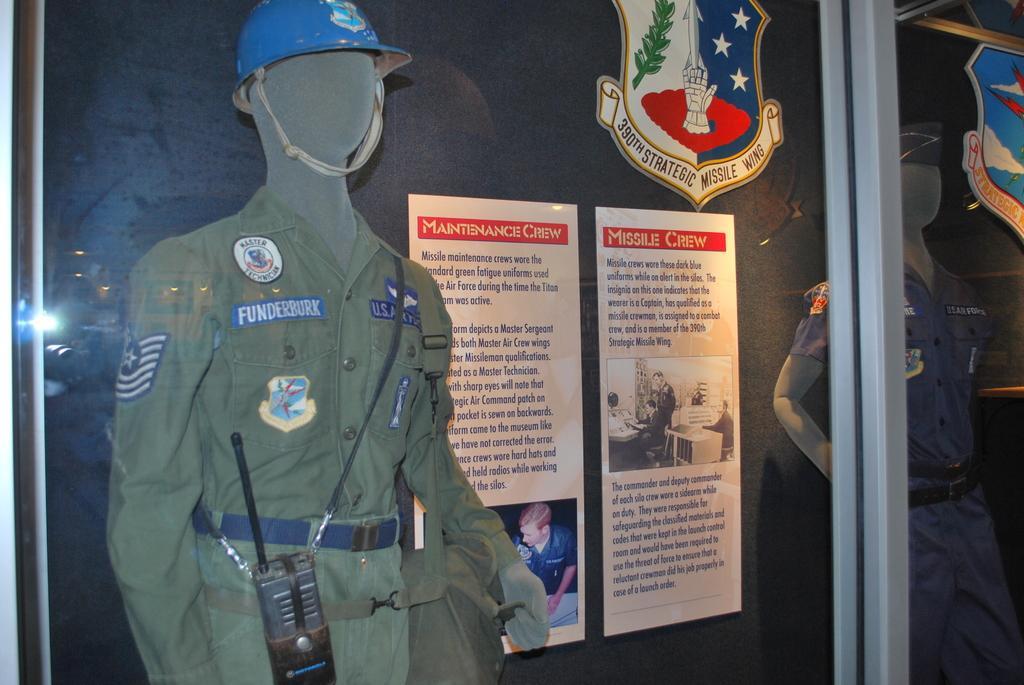Could you give a brief overview of what you see in this image? In this picture, we see the mannequin of the man in the uniform. Behind that, we see the boards or the posters with some text written. In the background, it is blue in color and it might be a board. In front of the picture, we see the glass on which two emblems are placed. 